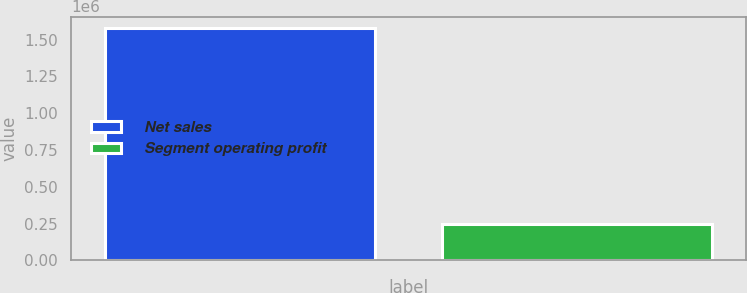Convert chart to OTSL. <chart><loc_0><loc_0><loc_500><loc_500><bar_chart><fcel>Net sales<fcel>Segment operating profit<nl><fcel>1.57672e+06<fcel>246508<nl></chart> 